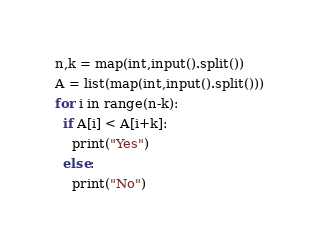Convert code to text. <code><loc_0><loc_0><loc_500><loc_500><_Python_>n,k = map(int,input().split())
A = list(map(int,input().split()))
for i in range(n-k):
  if A[i] < A[i+k]:
    print("Yes")
  else:
    print("No")</code> 